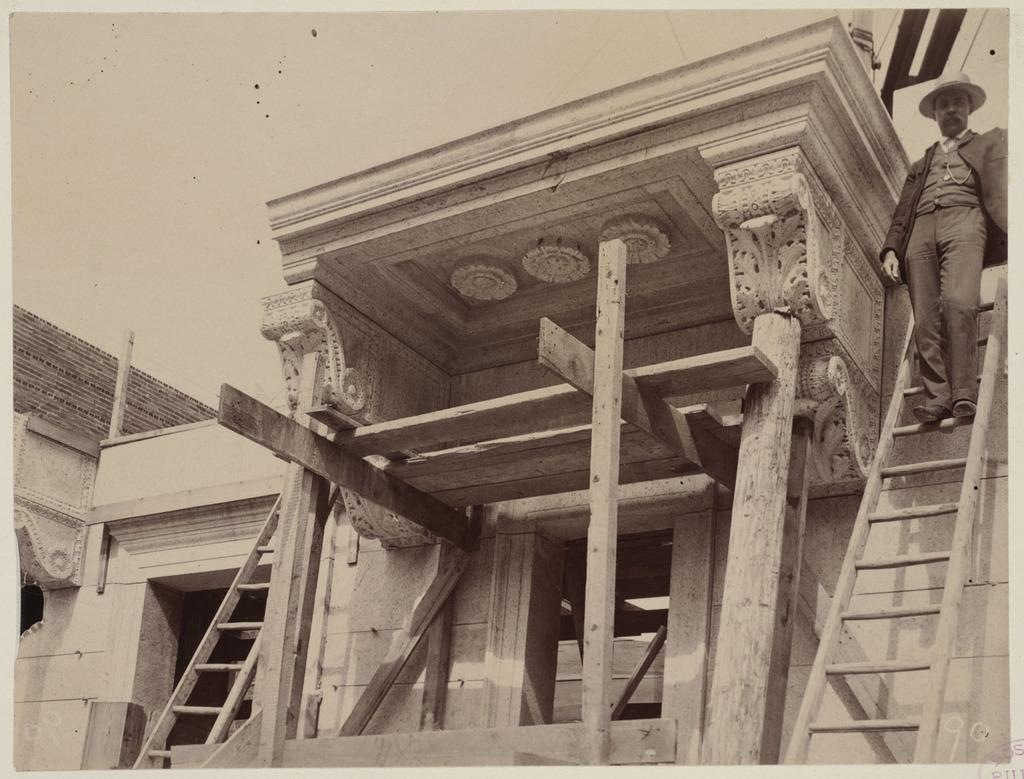What is the color scheme of the image? The image is black and white. Who or what can be seen in the image? There is a man in the image. What is the man doing in the image? The man is standing on a ladder. How is the ladder positioned in the image? The ladder is attached to a building. What is the name of the man in the image? The provided facts do not mention the name of the man in the image. Can you see any gloves in the image? There is no mention of gloves in the provided facts, so we cannot determine if any are present in the image. 